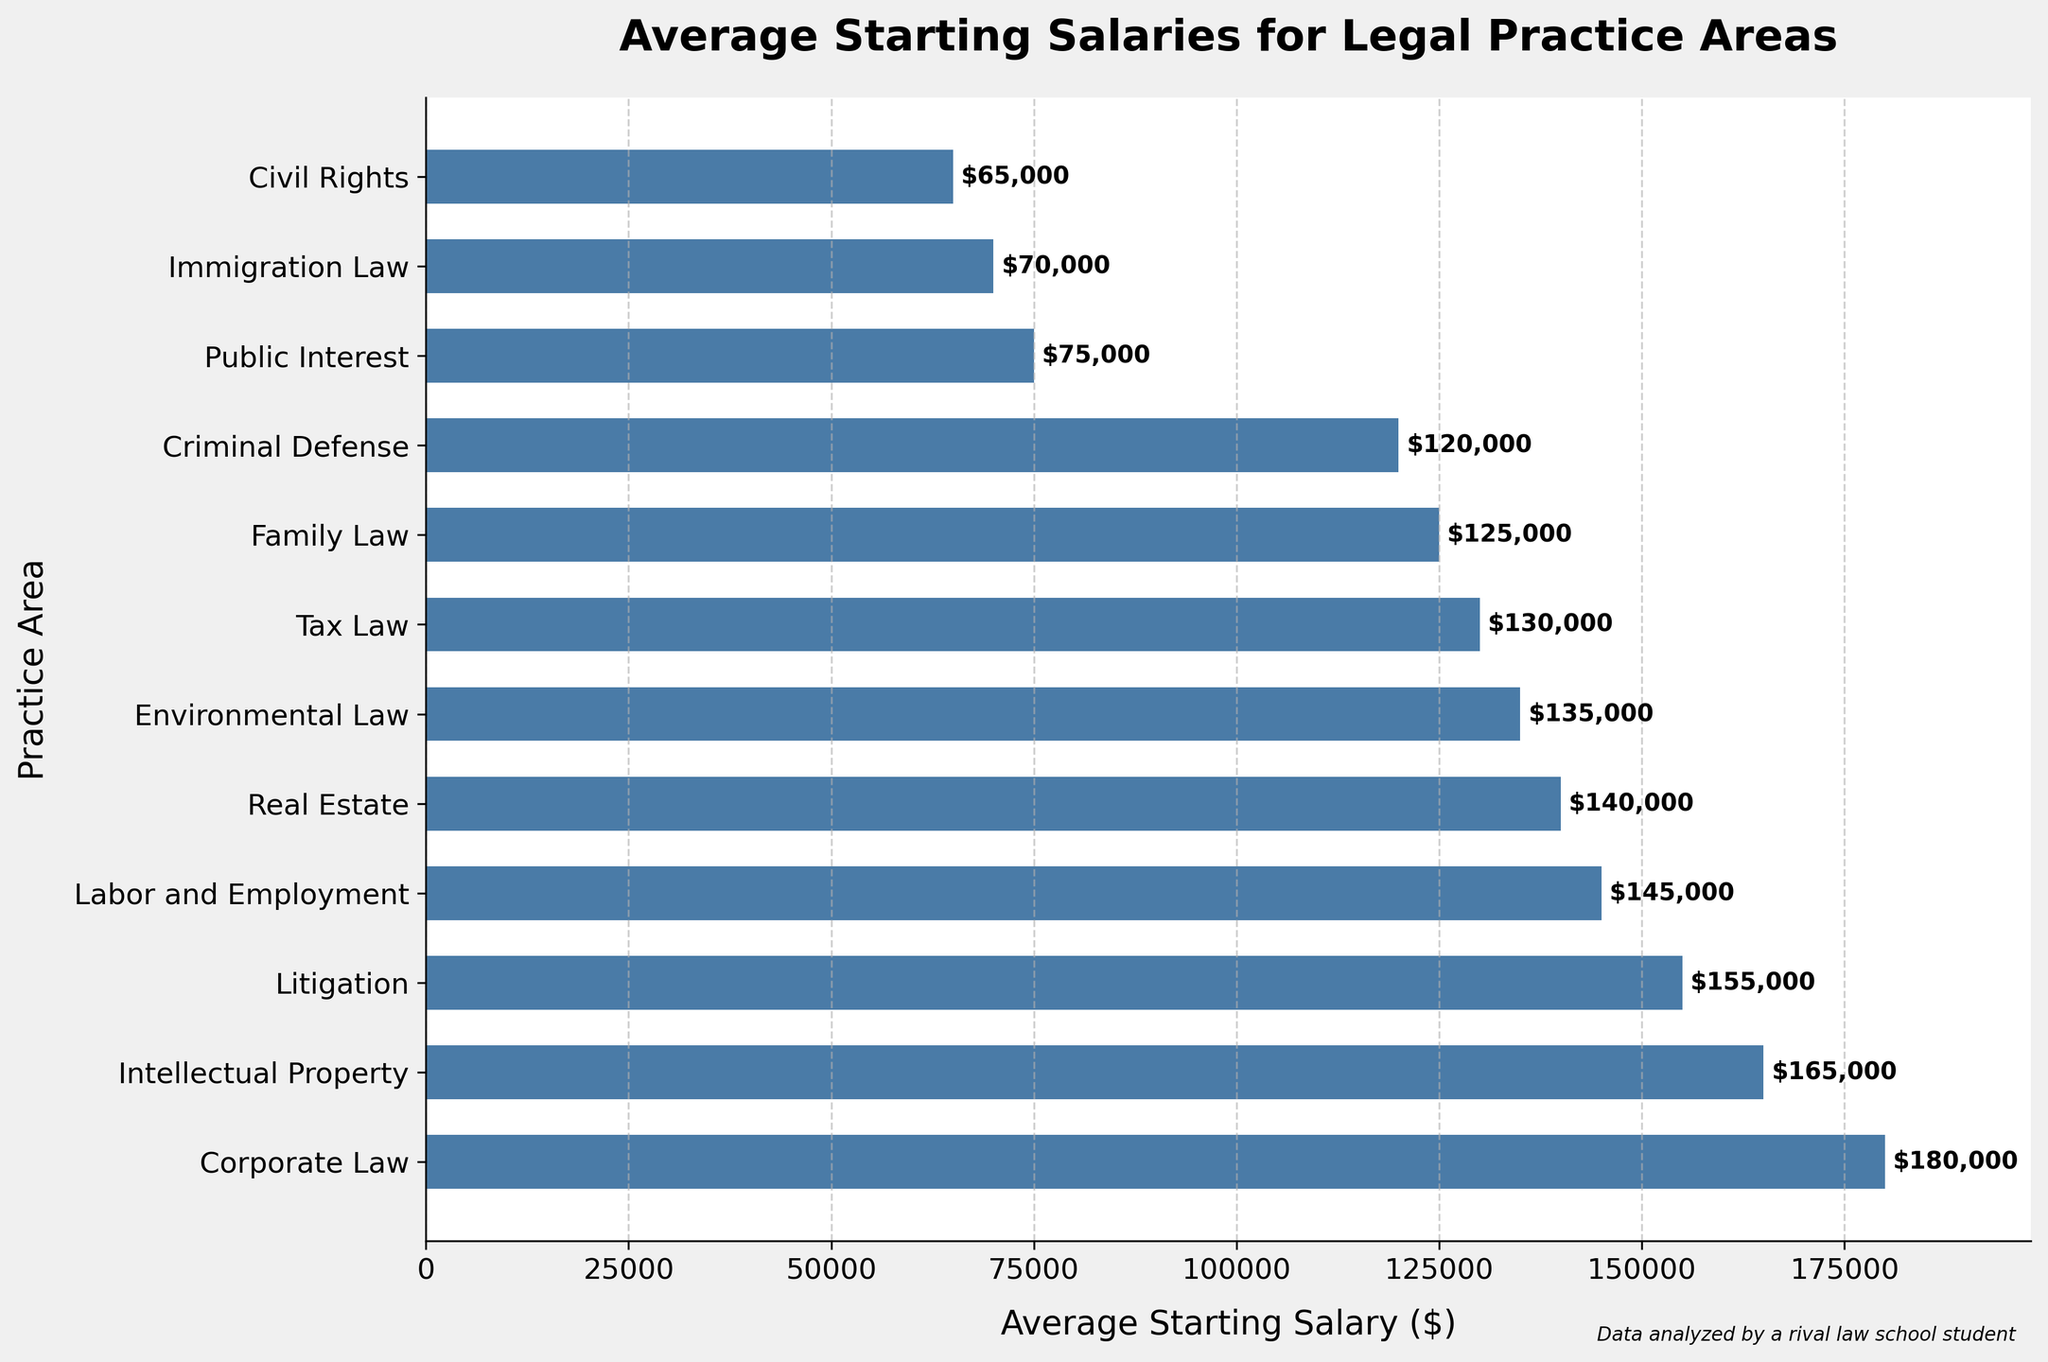What's the difference in average starting salaries between the highest and lowest paying practice areas? The highest-paying practice area is Corporate Law with $180,000, and the lowest-paying is Civil Rights with $65,000. The difference is $180,000 - $65,000.
Answer: $115,000 Which practice area has the median average starting salary? Listing the salaries in ascending order: $65,000, $70,000, $75,000, $120,000, $125,000, $130,000, $135,000, $140,000, $145,000, $155,000, $165,000, $180,000, Tax Law has the median salary.
Answer: Tax Law Which three practice areas have average starting salaries above $150,000? Reviewing the chart, Corporate Law ($180,000), Intellectual Property ($165,000), and Litigation ($155,000) have salaries exceeding $150,000.
Answer: Corporate Law, Intellectual Property, and Litigation By what percentage is the average starting salary in Corporate Law higher than in Environmental Law? Corporate Law has $180,000, and Environmental Law has $135,000. The percentage increase is ((180,000 - 135,000) / 135,000) * 100.
Answer: 33.33% How much more do new Corporate Law attorneys make compared to new Public Interest attorneys? The average starting salary in Corporate Law is $180,000, while in Public Interest it's $75,000. The difference is $180,000 - $75,000.
Answer: $105,000 Which practice area has the second lowest average starting salary? According to the figure, Immigration Law has the second lowest salary at $70,000, just above Civil Rights.
Answer: Immigration Law Is the average starting salary for Real Estate greater than or less than that for Labor and Employment? Real Estate has an average starting salary of $140,000, while Labor and Employment is slightly higher at $145,000.
Answer: Less than What is the combined total average starting salary of the three lowest-paying practice areas? The salaries for Civil Rights, Immigration Law, and Public Interest are $65,000, $70,000, and $75,000 respectively. The total is $65,000 + $70,000 + $75,000.
Answer: $210,000 How do the average starting salaries for Family Law and Criminal Defense compare to each other? Family Law offers an average starting salary of $125,000, while Criminal Defense is slightly lower at $120,000.
Answer: Family Law is higher What is the average starting salary for the practice areas earning above $100,000 but below $150,000? Salaries in this range are Litigation ($155,000), Labor and Employment ($145,000), Real Estate ($140,000), Environmental Law ($135,000), Tax Law ($130,000), Family Law ($125,000), and Criminal Defense ($120,000). The average is (155,000 + 145,000 + 140,000 + 135,000 + 130,000 + 125,000 + 120,000) / 7.
Answer: $135,000 